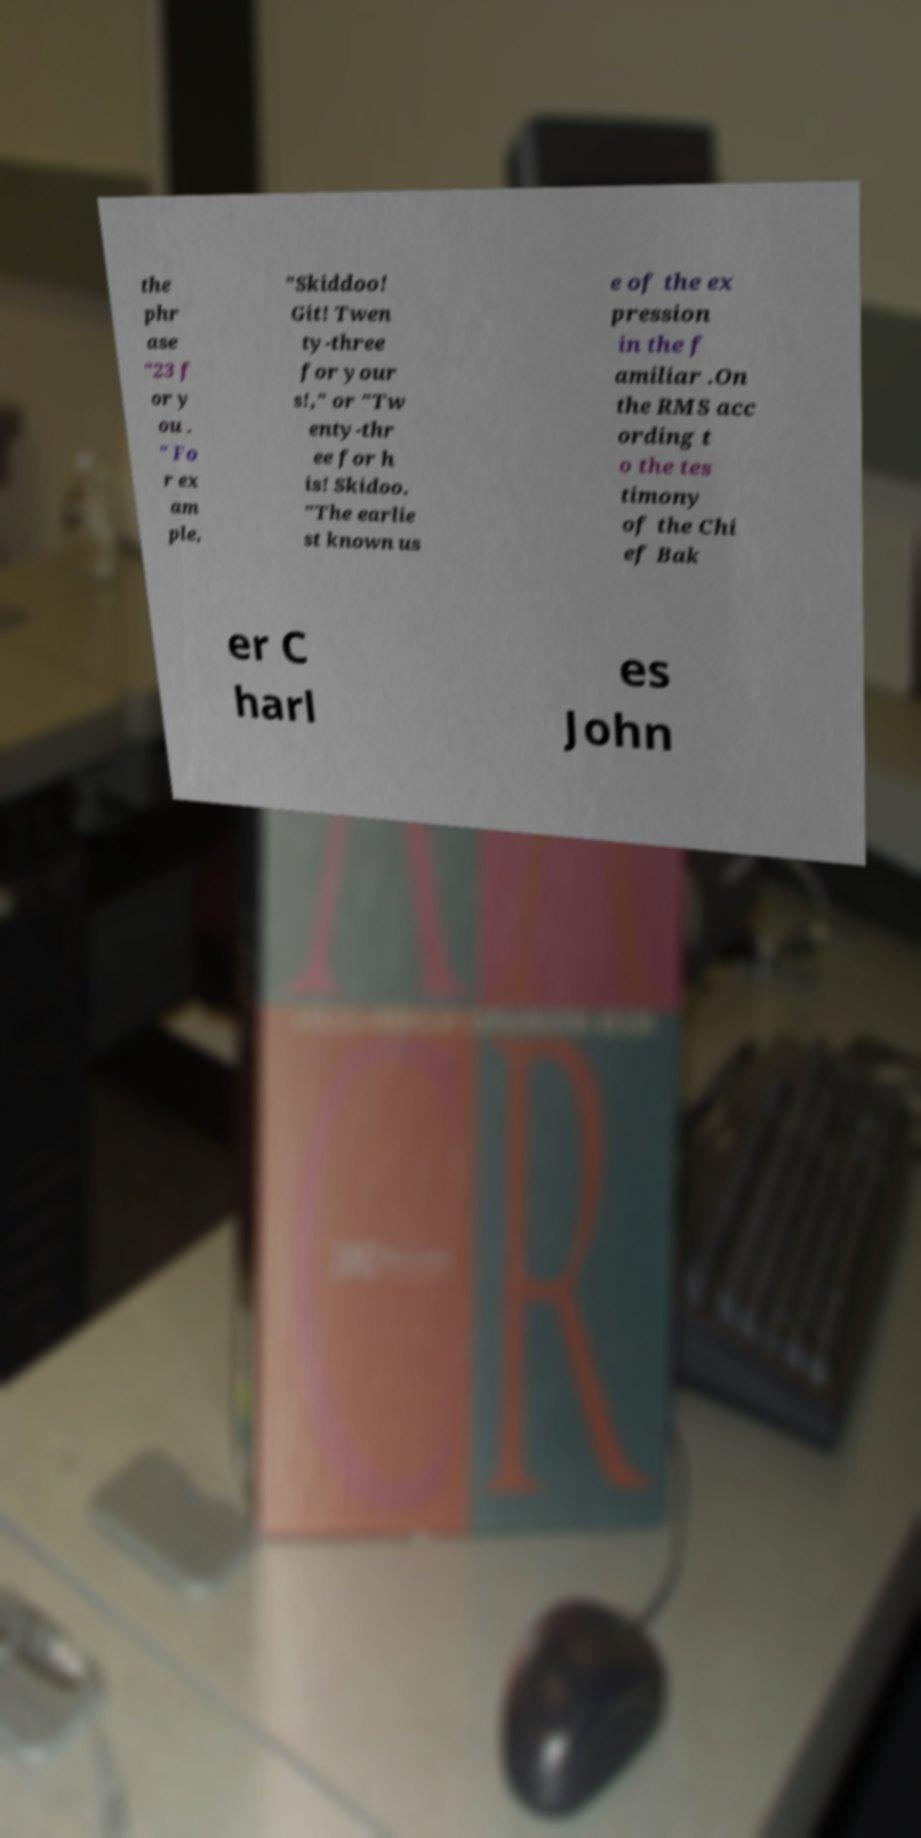Please read and relay the text visible in this image. What does it say? the phr ase "23 f or y ou . " Fo r ex am ple, "Skiddoo! Git! Twen ty-three for your s!," or "Tw enty-thr ee for h is! Skidoo. "The earlie st known us e of the ex pression in the f amiliar .On the RMS acc ording t o the tes timony of the Chi ef Bak er C harl es John 